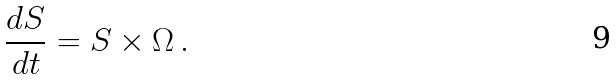Convert formula to latex. <formula><loc_0><loc_0><loc_500><loc_500>\frac { d { S } } { d t } = { S } \times { \Omega } \, .</formula> 